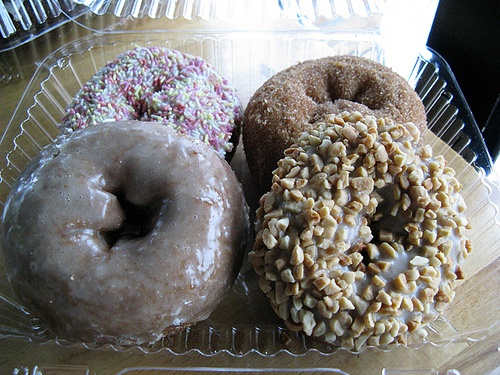Describe the objects in this image and their specific colors. I can see donut in lightblue, gray, black, darkgray, and lavender tones, donut in lightblue, black, darkgray, lightgray, and gray tones, donut in lightblue, black, darkgray, and gray tones, and donut in lightblue, lavender, darkgray, and gray tones in this image. 